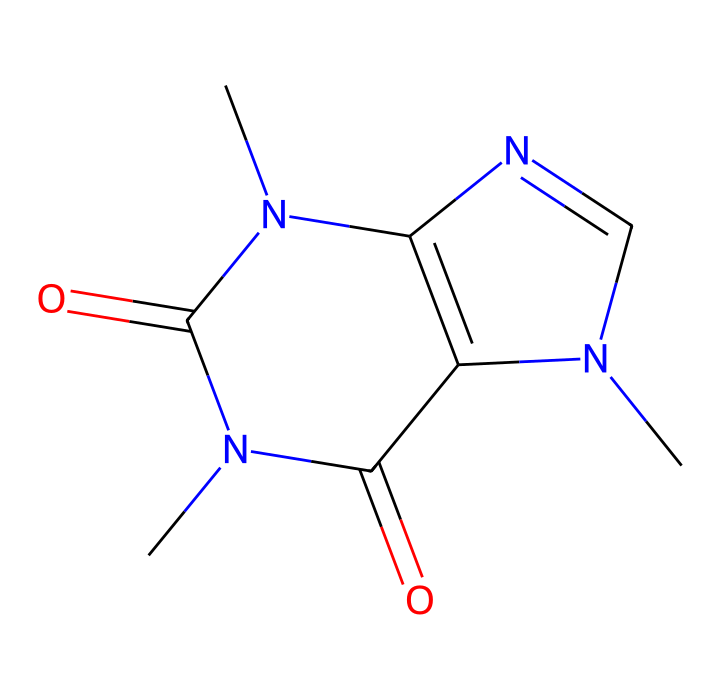What is the molecular formula of caffeine? To determine the molecular formula, we can analyze the SMILES representation for the types and counts of atoms present. In the SMILES, we can identify the following elements: carbon (C), nitrogen (N), and oxygen (O). Counting them gives us 8 carbon, 10 hydrogen, 4 nitrogen, and 2 oxygen. Therefore, the molecular formula is C8H10N4O2.
Answer: C8H10N4O2 How many nitrogen atoms are in caffeine? The SMILES representation contains the letter "N", which denotes nitrogen atoms. By counting the occurrences of "N" in the SMILES string, we find that there are 4 nitrogen atoms in the caffeine structure.
Answer: 4 What type of chemical structure is caffeine classified as? Caffeine possesses a complex ring structure characteristic of alkaloids due to the presence of nitrogen atoms in its formation. Alkaloids are typically derived from plant origins and exhibit pharmacological effects, making caffeine a member of this chemical class.
Answer: alkaloid What is the structural feature that contributes to caffeine’s stimulant properties? The presence of multiple nitrogen atoms in a fused ring system gives caffeine its stimulant properties. This structural characteristic allows caffeine to interact effectively with neurotransmitter receptors in the brain, leading to increased alertness.
Answer: nitrogen atoms Which functional groups are present in caffeine? Analyzing the SMILES structure, we can identify the presence of carbonyl groups (C=O) and amine groups (N). The carbonyls contribute to the reactivity and properties of caffeine, while the amines are indicative of its alkaloid classification.
Answer: carbonyl and amine groups 